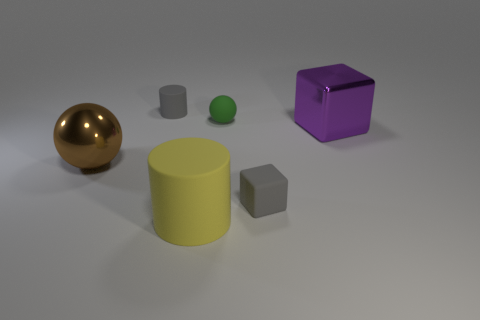Are there any purple blocks made of the same material as the big brown thing?
Your answer should be compact. Yes. Is the size of the block that is in front of the shiny cube the same as the brown metallic sphere?
Make the answer very short. No. What number of yellow things are either big matte objects or rubber cylinders?
Offer a very short reply. 1. What material is the gray thing that is right of the tiny green sphere?
Make the answer very short. Rubber. How many gray matte cubes are in front of the tiny gray thing in front of the green matte sphere?
Give a very brief answer. 0. How many other objects have the same shape as the big purple object?
Offer a very short reply. 1. What number of large yellow cubes are there?
Make the answer very short. 0. There is a big metal ball that is on the left side of the small gray rubber cube; what color is it?
Offer a very short reply. Brown. There is a matte cylinder that is in front of the small gray thing on the left side of the green ball; what is its color?
Your response must be concise. Yellow. The rubber sphere that is the same size as the gray matte cube is what color?
Offer a terse response. Green. 